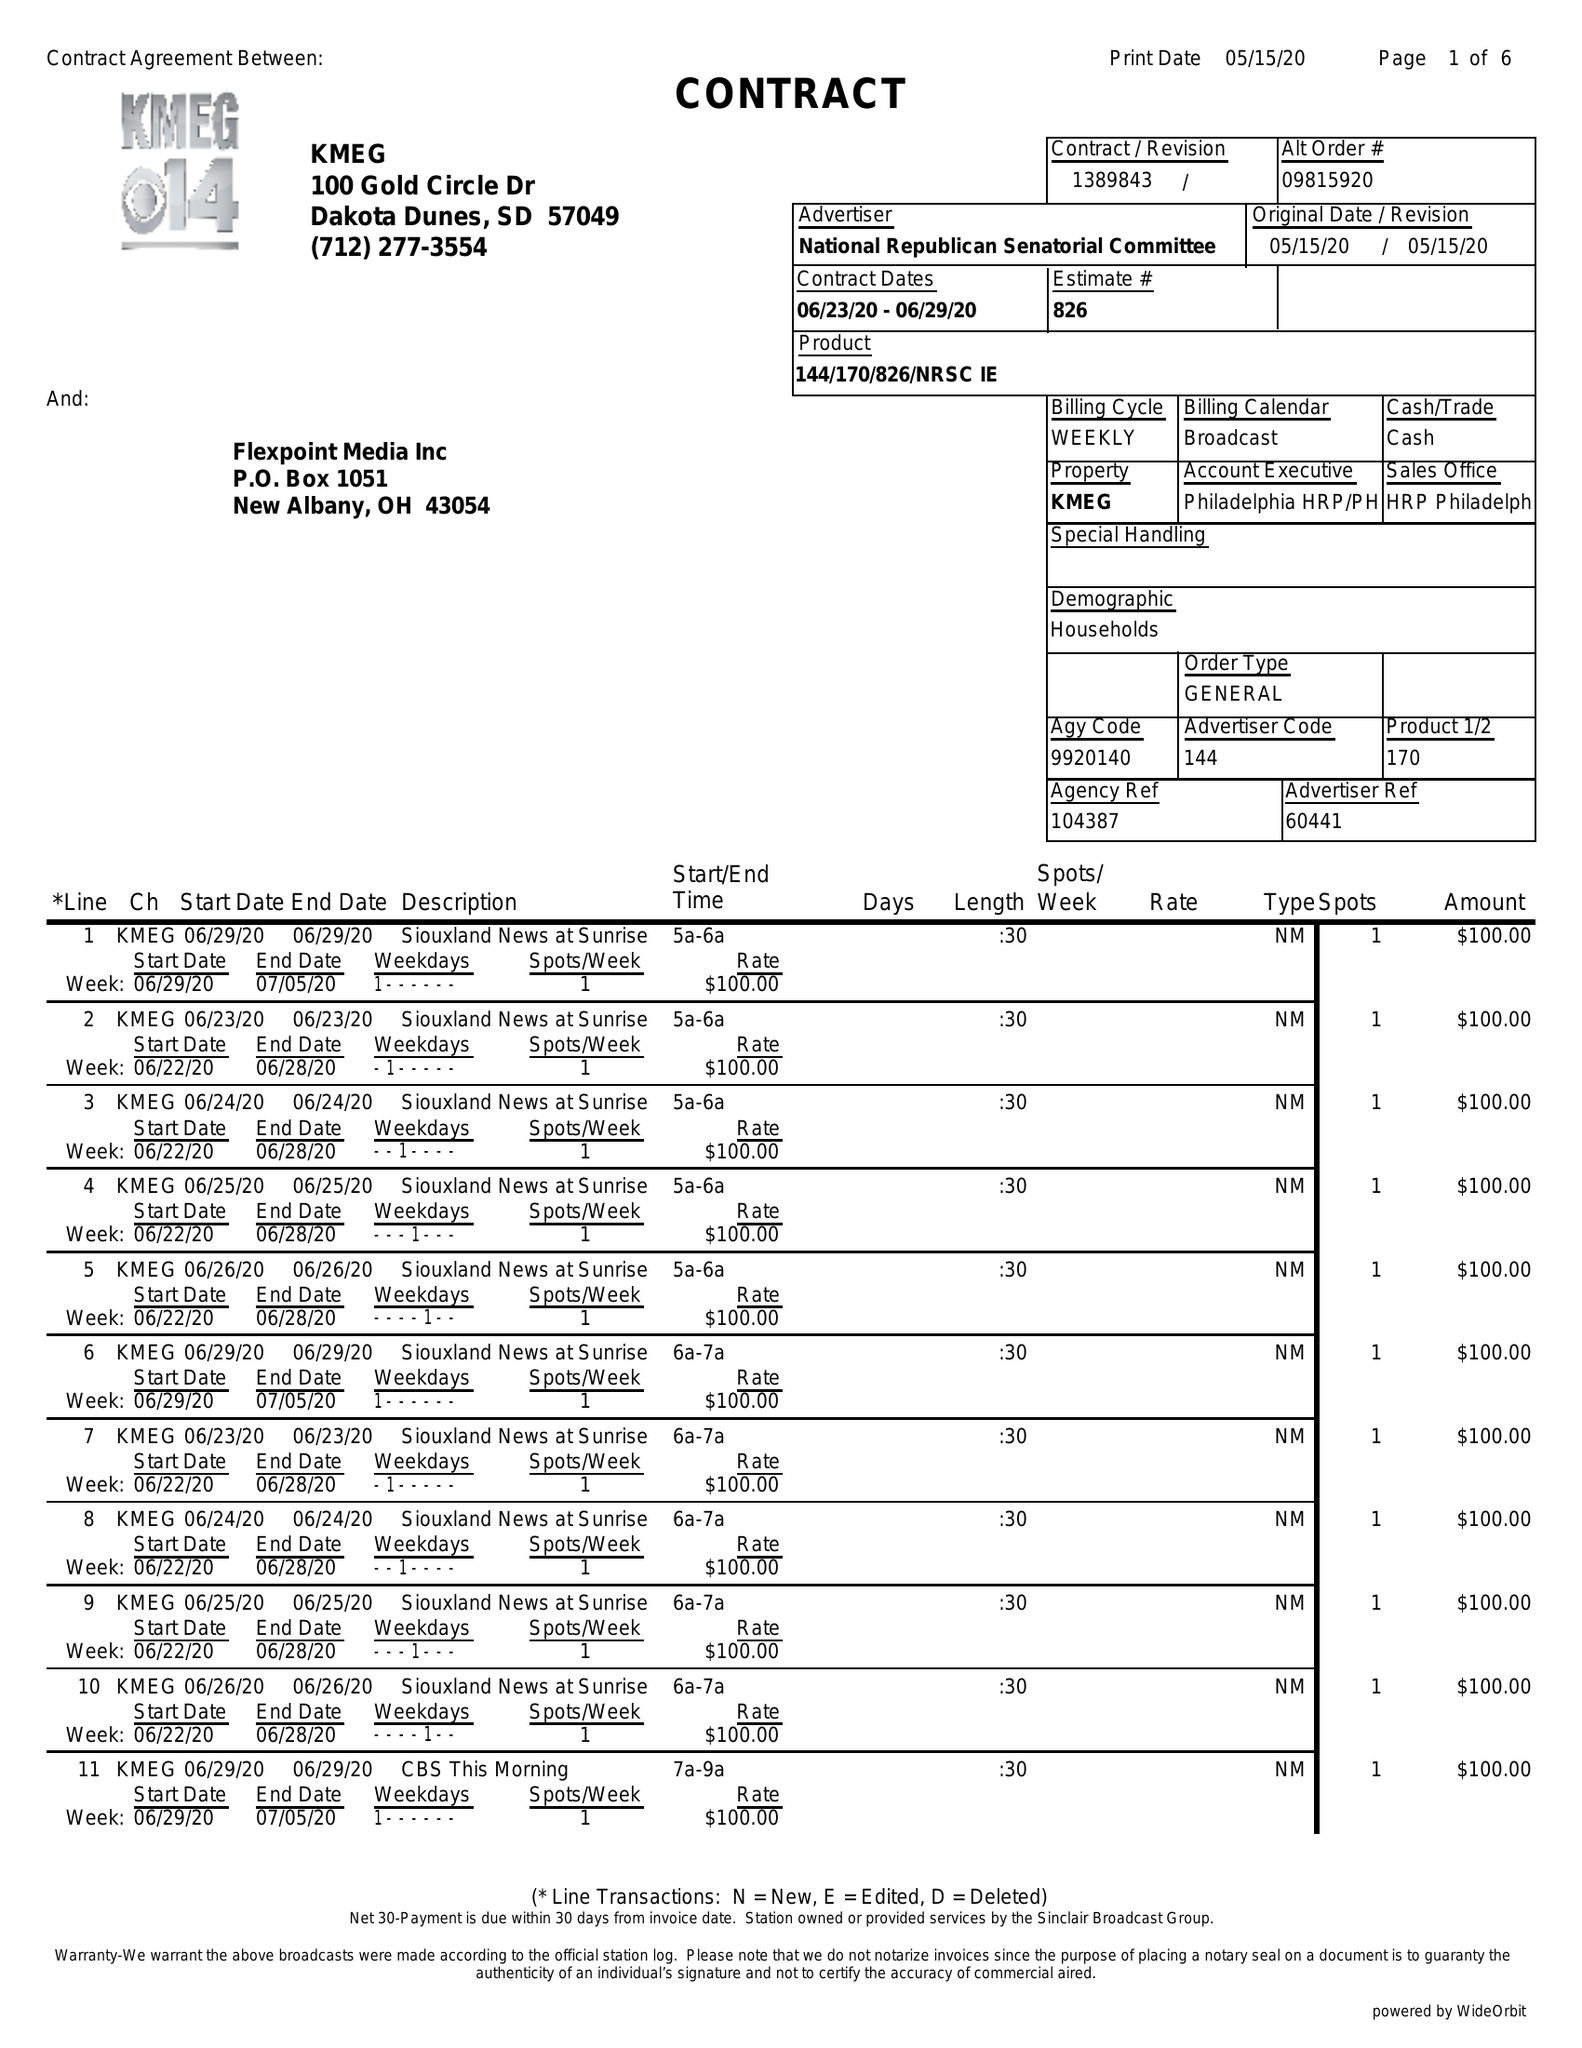What is the value for the flight_from?
Answer the question using a single word or phrase. 06/23/20 